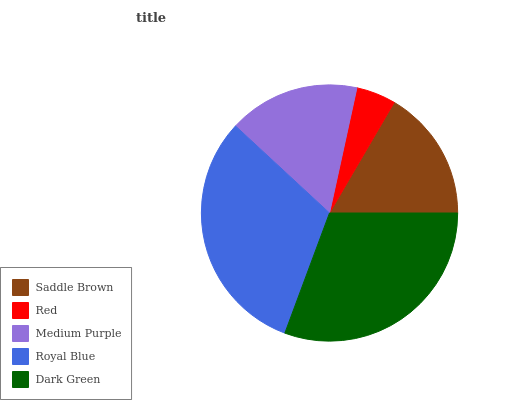Is Red the minimum?
Answer yes or no. Yes. Is Royal Blue the maximum?
Answer yes or no. Yes. Is Medium Purple the minimum?
Answer yes or no. No. Is Medium Purple the maximum?
Answer yes or no. No. Is Medium Purple greater than Red?
Answer yes or no. Yes. Is Red less than Medium Purple?
Answer yes or no. Yes. Is Red greater than Medium Purple?
Answer yes or no. No. Is Medium Purple less than Red?
Answer yes or no. No. Is Saddle Brown the high median?
Answer yes or no. Yes. Is Saddle Brown the low median?
Answer yes or no. Yes. Is Red the high median?
Answer yes or no. No. Is Red the low median?
Answer yes or no. No. 